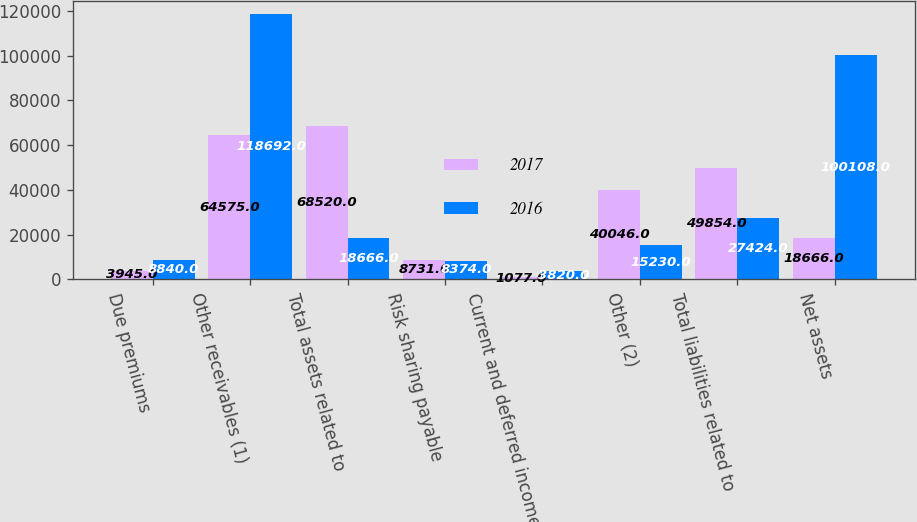Convert chart to OTSL. <chart><loc_0><loc_0><loc_500><loc_500><stacked_bar_chart><ecel><fcel>Due premiums<fcel>Other receivables (1)<fcel>Total assets related to<fcel>Risk sharing payable<fcel>Current and deferred income<fcel>Other (2)<fcel>Total liabilities related to<fcel>Net assets<nl><fcel>2017<fcel>3945<fcel>64575<fcel>68520<fcel>8731<fcel>1077<fcel>40046<fcel>49854<fcel>18666<nl><fcel>2016<fcel>8840<fcel>118692<fcel>18666<fcel>8374<fcel>3820<fcel>15230<fcel>27424<fcel>100108<nl></chart> 